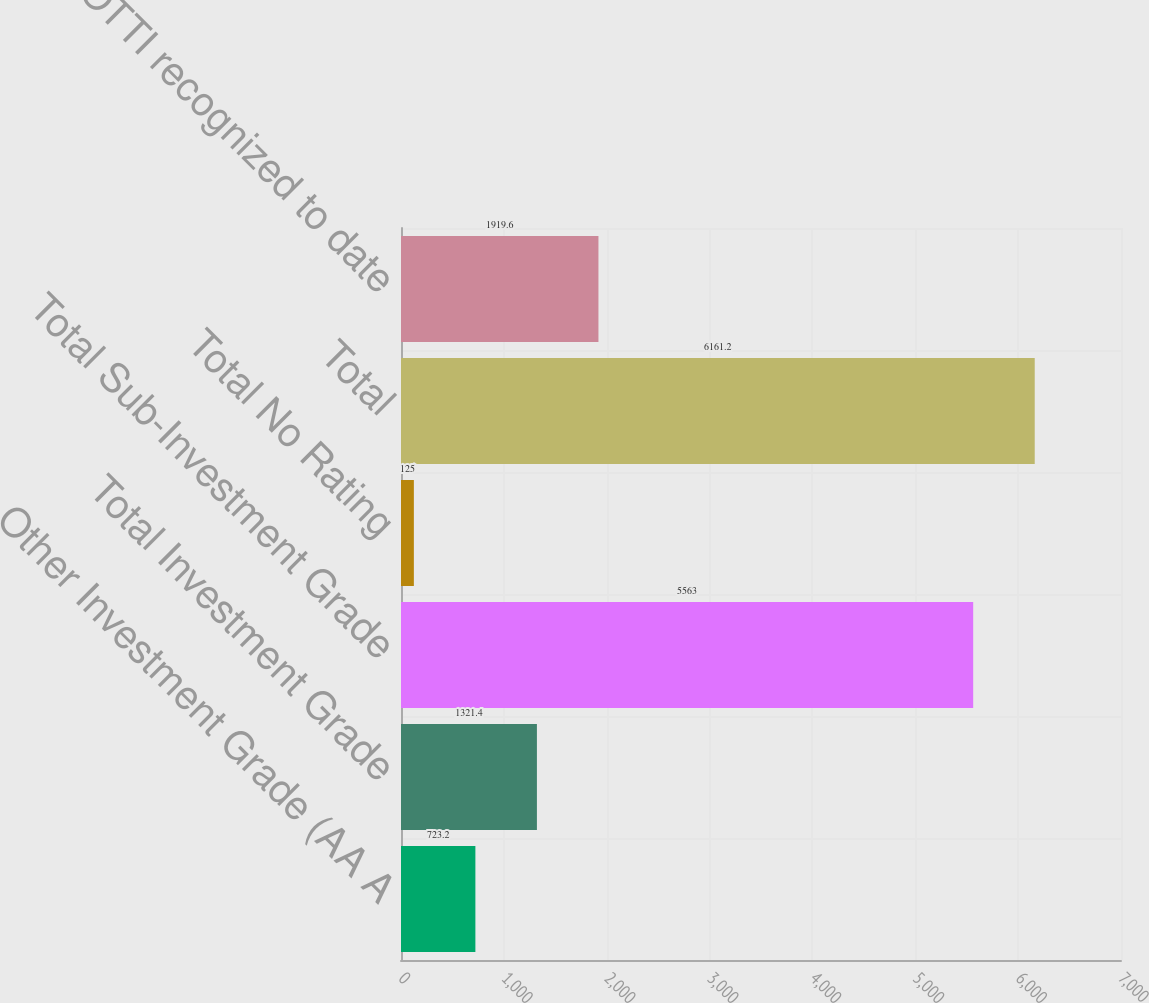Convert chart. <chart><loc_0><loc_0><loc_500><loc_500><bar_chart><fcel>Other Investment Grade (AA A<fcel>Total Investment Grade<fcel>Total Sub-Investment Grade<fcel>Total No Rating<fcel>Total<fcel>No OTTI recognized to date<nl><fcel>723.2<fcel>1321.4<fcel>5563<fcel>125<fcel>6161.2<fcel>1919.6<nl></chart> 